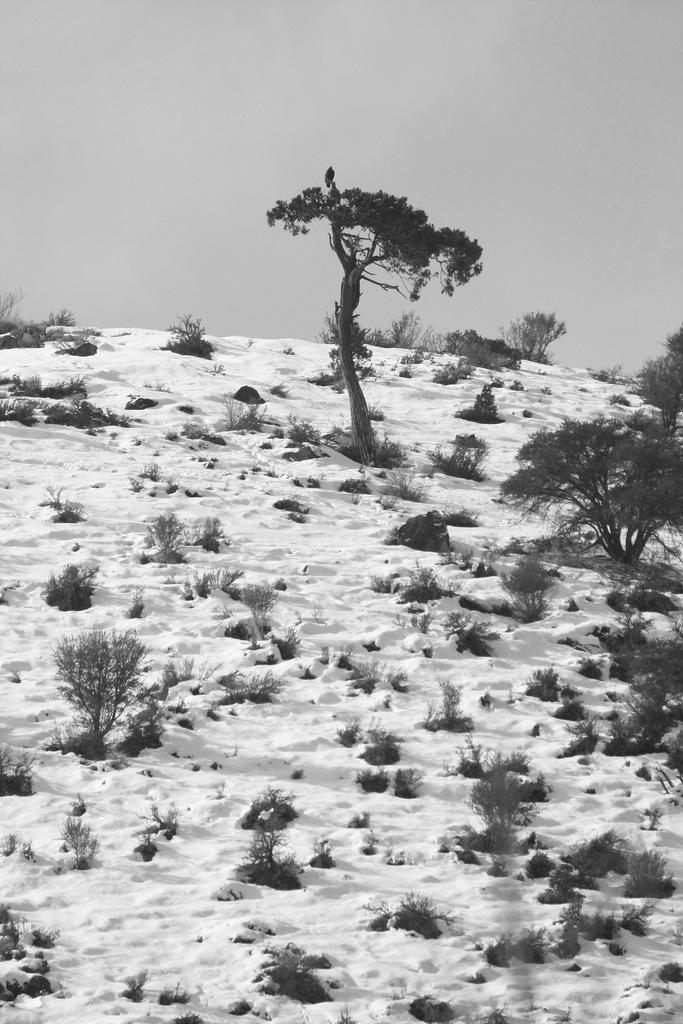Could you give a brief overview of what you see in this image? This image consists of trees and plants. At the bottom, there is snow. At the top, there is sky. And we can see a bird on the tree. 